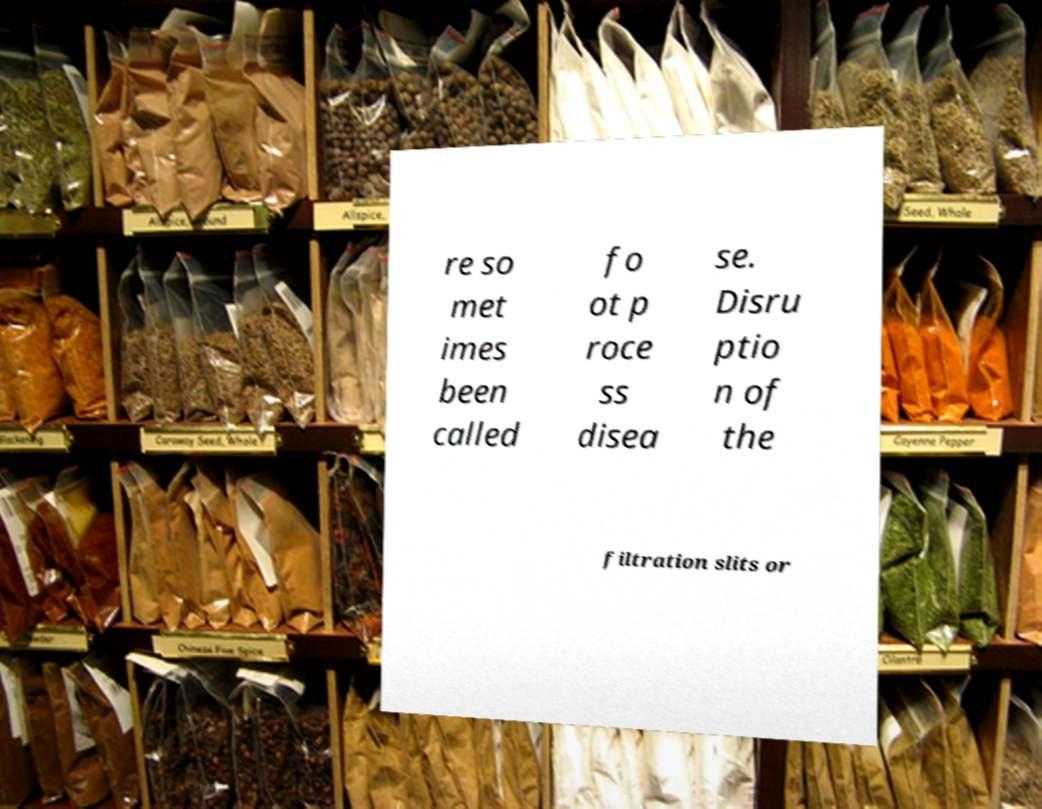Could you extract and type out the text from this image? re so met imes been called fo ot p roce ss disea se. Disru ptio n of the filtration slits or 